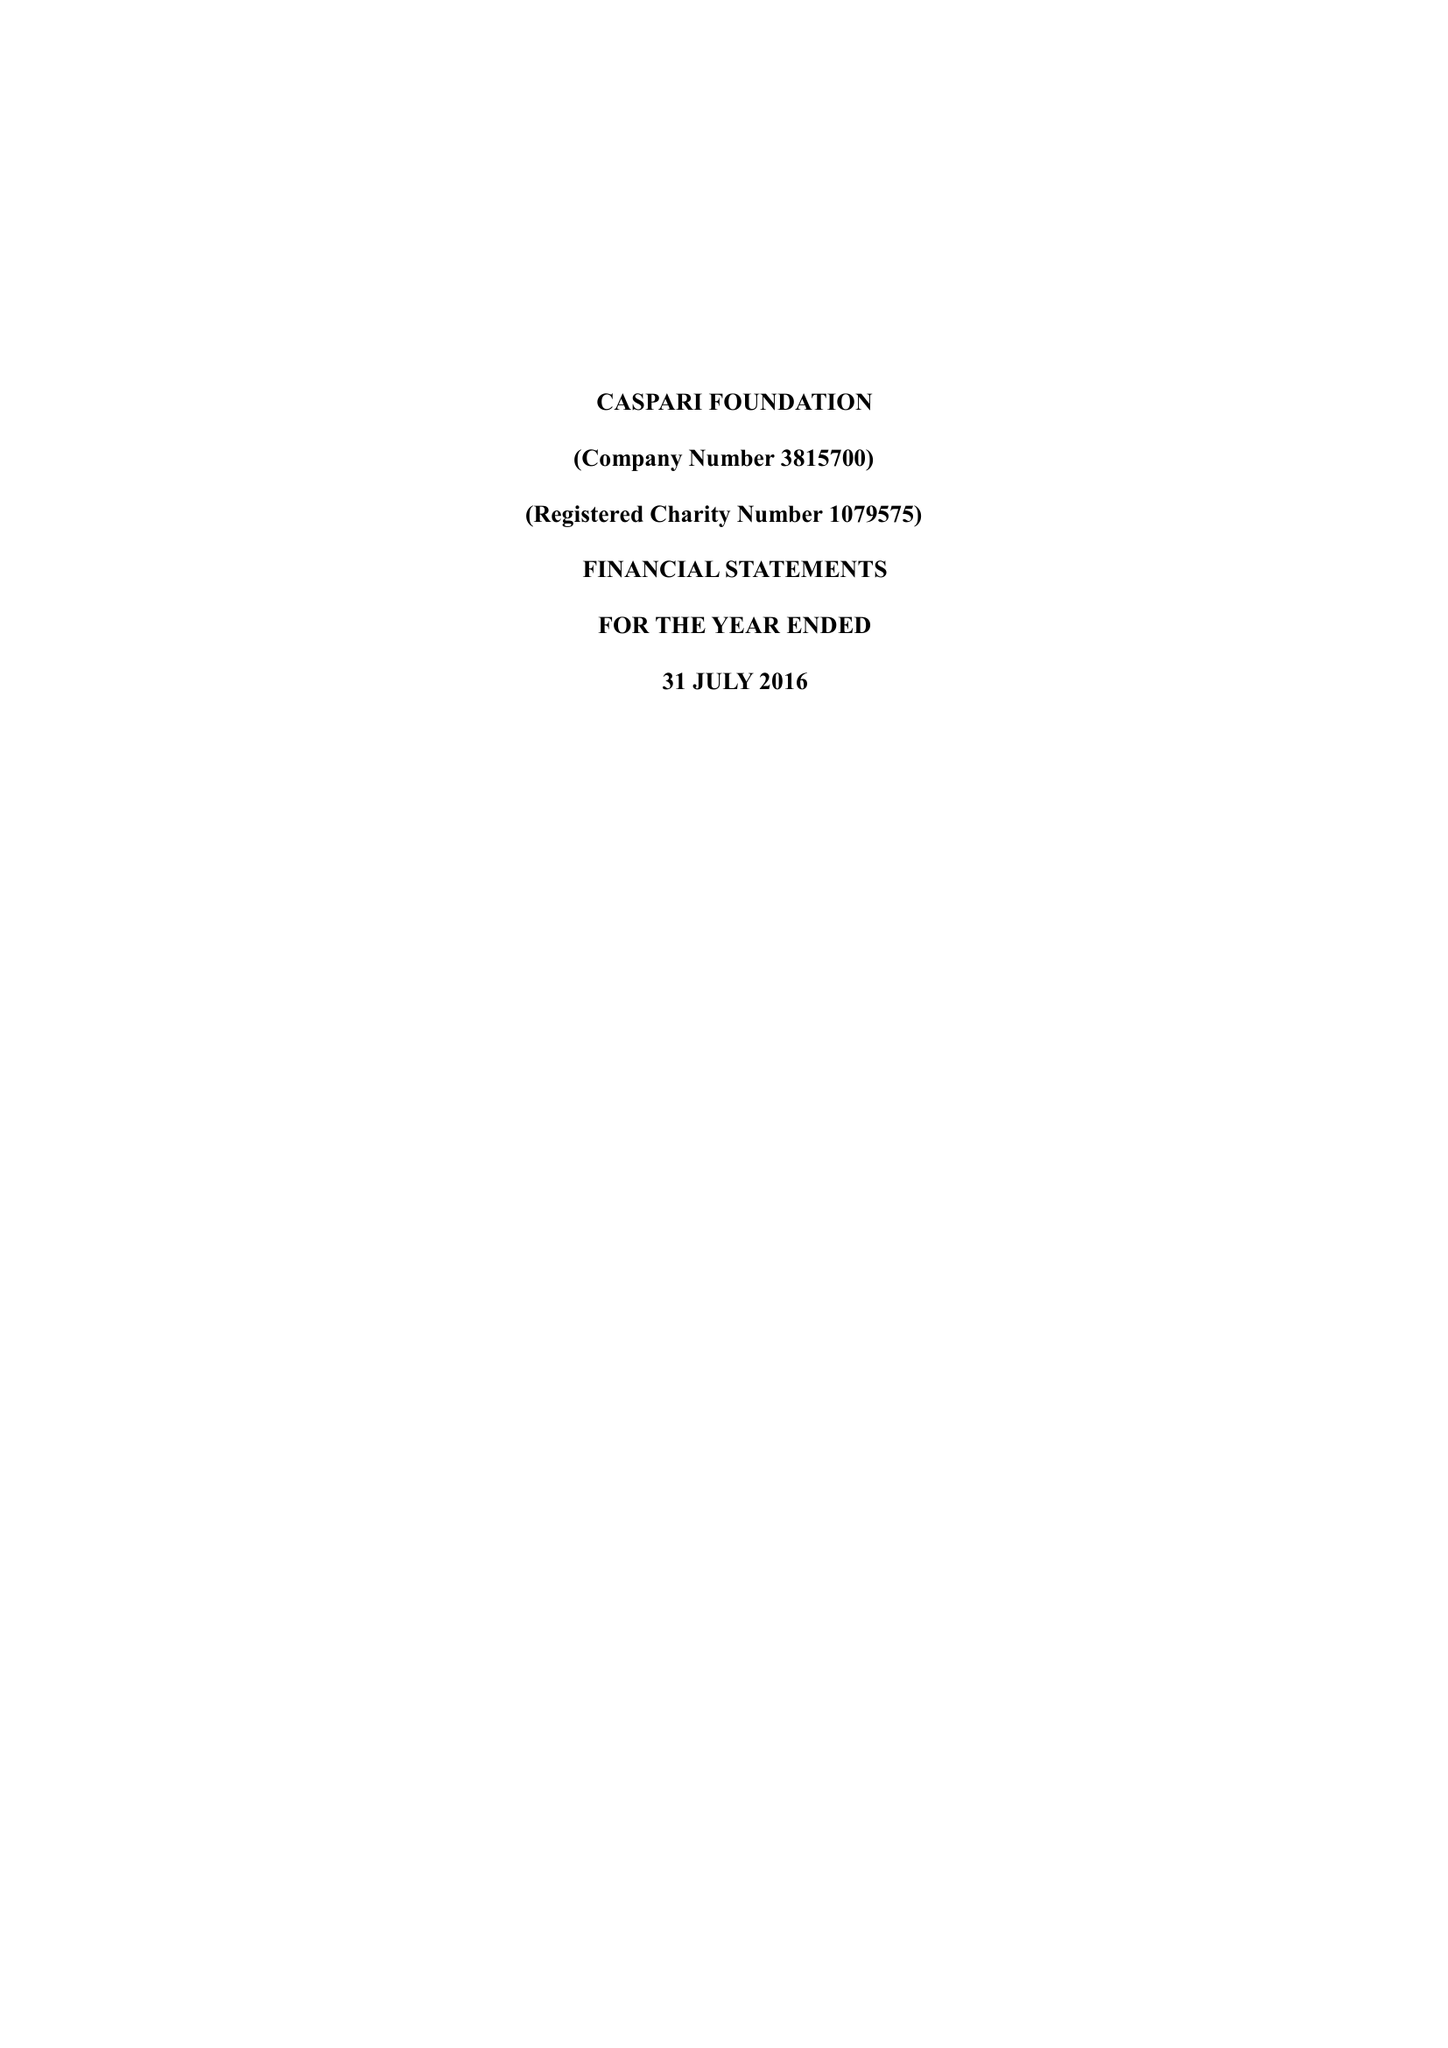What is the value for the spending_annually_in_british_pounds?
Answer the question using a single word or phrase. 151250.00 